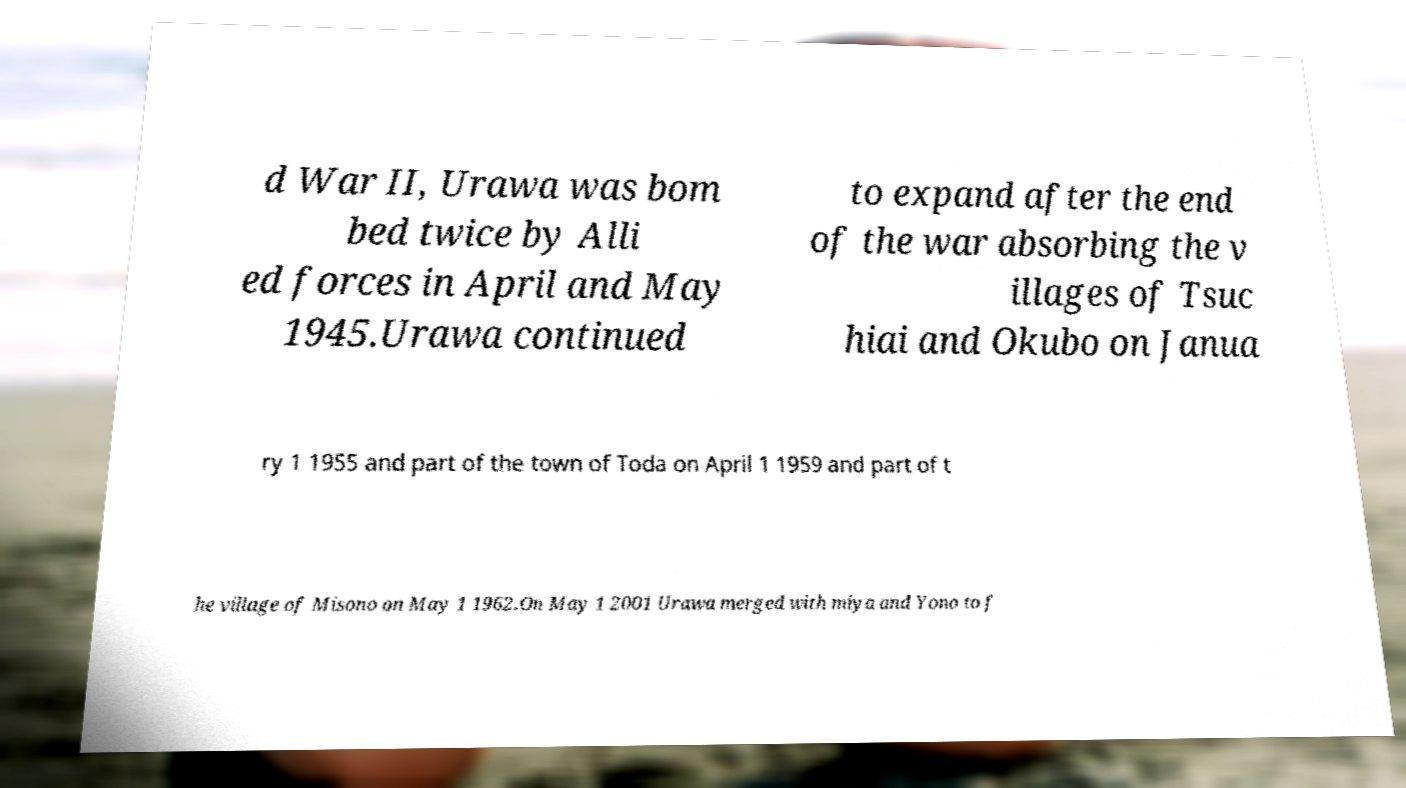There's text embedded in this image that I need extracted. Can you transcribe it verbatim? d War II, Urawa was bom bed twice by Alli ed forces in April and May 1945.Urawa continued to expand after the end of the war absorbing the v illages of Tsuc hiai and Okubo on Janua ry 1 1955 and part of the town of Toda on April 1 1959 and part of t he village of Misono on May 1 1962.On May 1 2001 Urawa merged with miya and Yono to f 